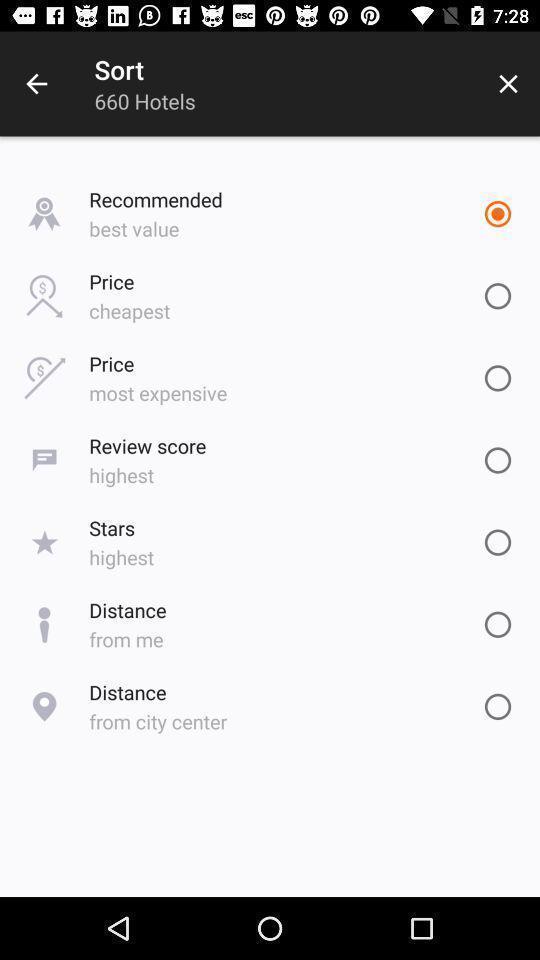What can you discern from this picture? Page shows the different hotel sort options. 